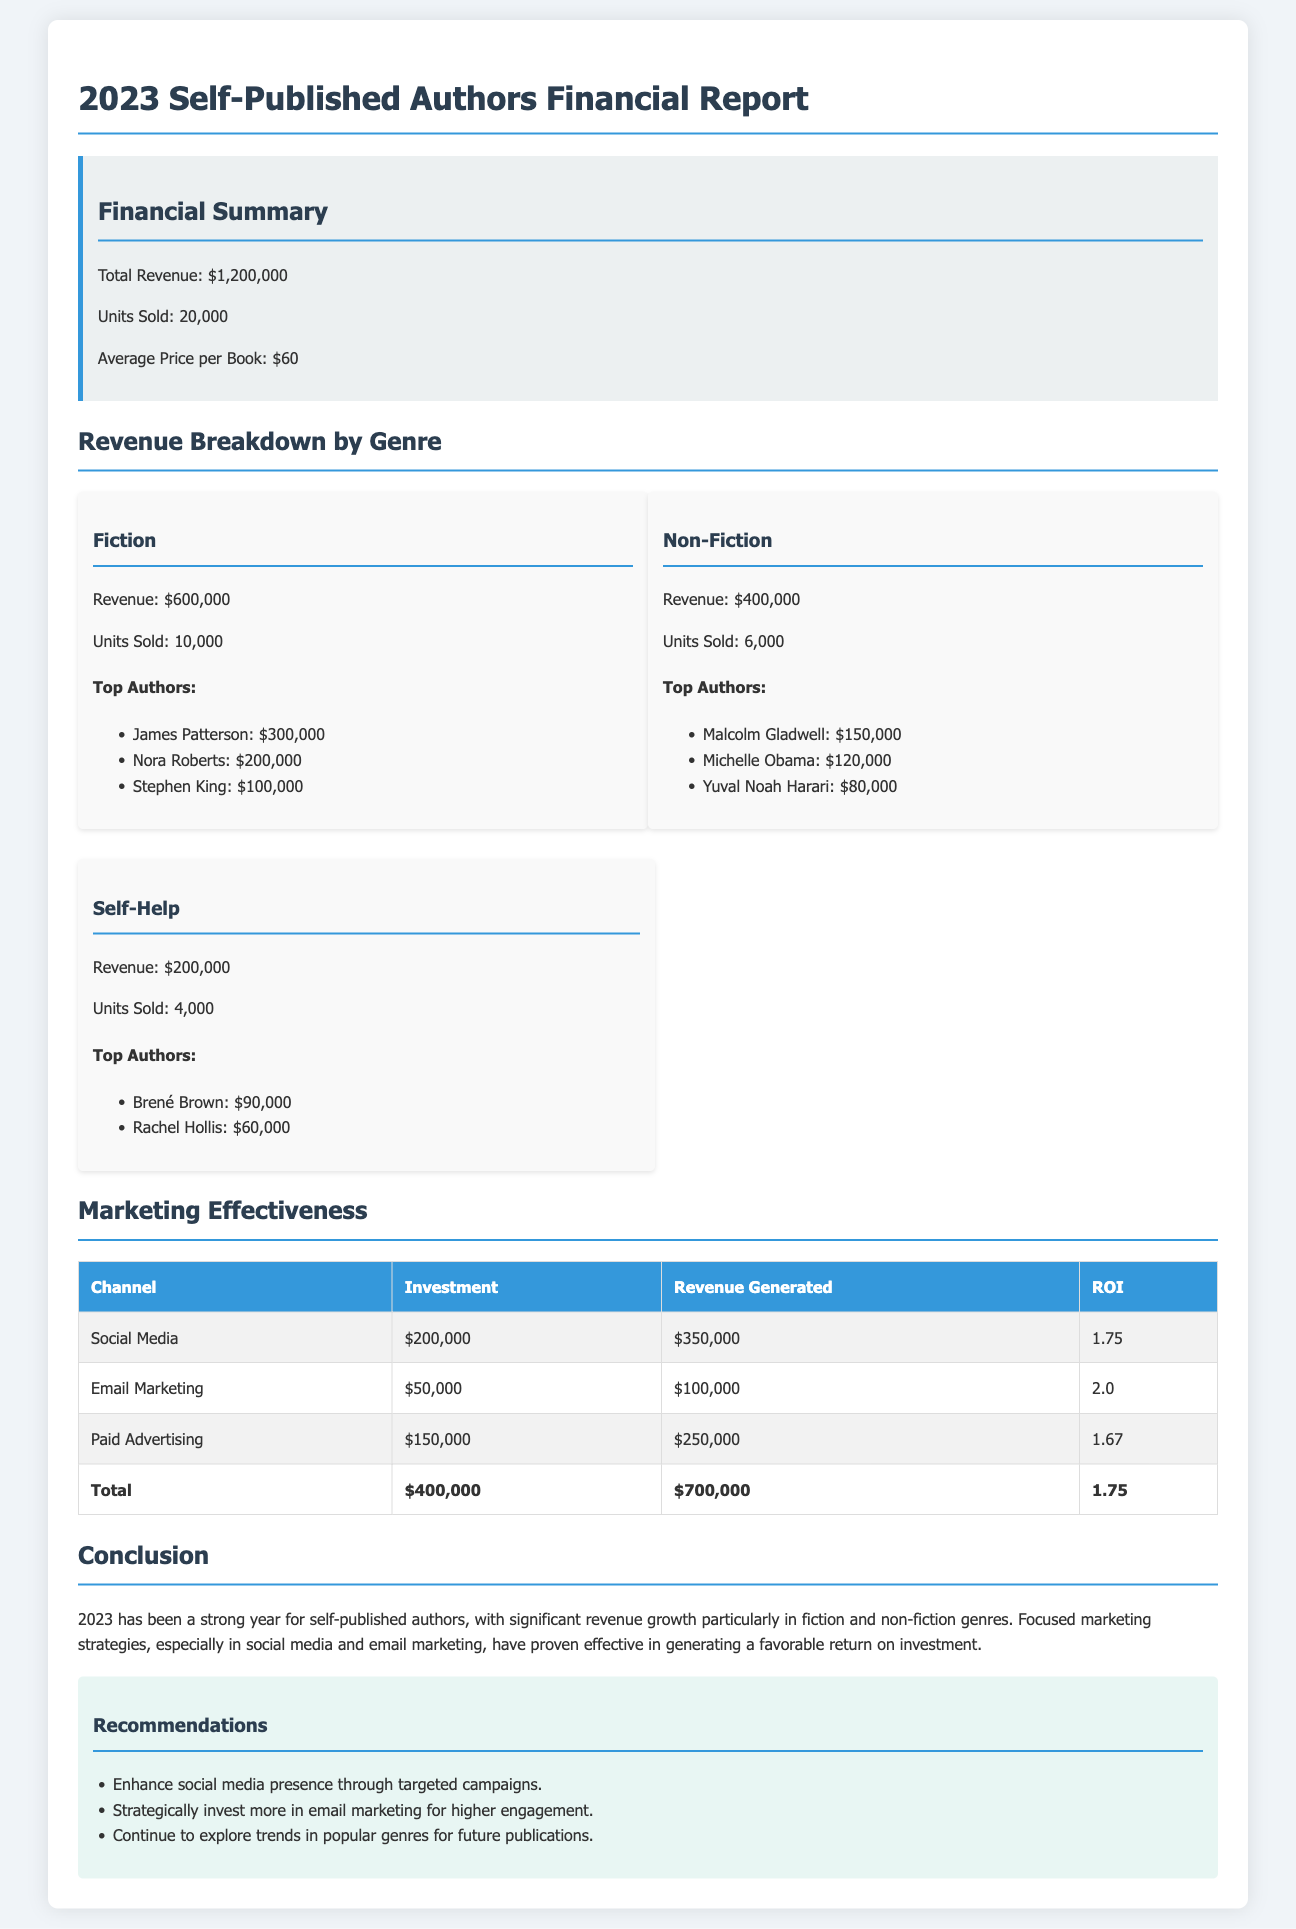What is the total revenue? The total revenue is stated as $1,200,000 in the financial summary.
Answer: $1,200,000 How many units were sold? The document specifies that 20,000 units were sold in 2023.
Answer: 20,000 Which genre generated the highest revenue? The revenue breakdown shows that Fiction generated the highest revenue of $600,000.
Answer: Fiction What is the ROI for Email Marketing? The table indicates that the ROI for Email Marketing is 2.0.
Answer: 2.0 Who are the top authors in Non-Fiction? The document lists Malcolm Gladwell, Michelle Obama, and Yuval Noah Harari as the top authors in Non-Fiction.
Answer: Malcolm Gladwell, Michelle Obama, Yuval Noah Harari What was the investment in Social Media? The financial report states that the investment in Social Media was $200,000.
Answer: $200,000 What percentage of total revenue does Self-Help represent? Self-Help generated $200,000, representing a significant fraction of the total revenue of $1,200,000, which can be calculated as approximately 16.67%.
Answer: 16.67% What are the recommendations for marketing strategies? The report recommends enhancing social media presence, investing in email marketing, and exploring popular genres.
Answer: Enhance social media presence, invest in email marketing, explore popular genres What was the revenue generated from Paid Advertising? The document provides that the revenue generated from Paid Advertising is $250,000.
Answer: $250,000 